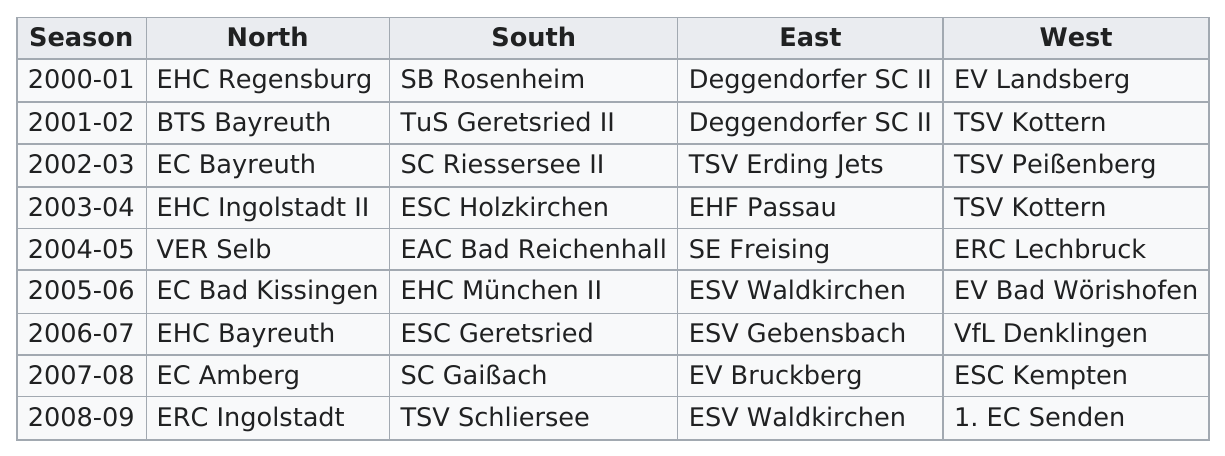Draw attention to some important aspects in this diagram. The number of times Deggendorfer's Sc II is listed on the 2.. list is 2. EHC Regensburg is the only team to have won the North division in the 2000-2001 season. The EHF Passau played for the East in 2002-2003, and the following year, the East was represented by the ERDING Jets. Gerhard Degendorfer has played in multiple seasons besides the 2000-01 season, including the 2001-02 season. It is reported that a total of 9 champions are present in the northern region. 